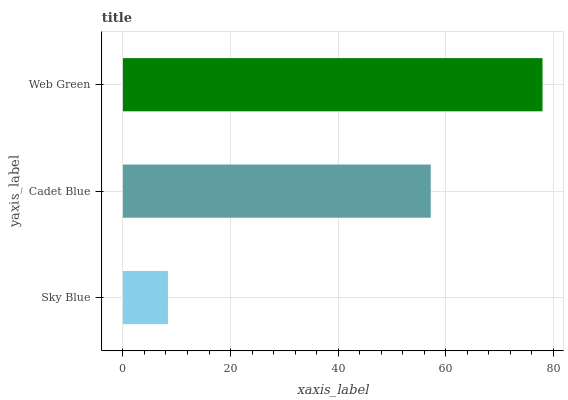Is Sky Blue the minimum?
Answer yes or no. Yes. Is Web Green the maximum?
Answer yes or no. Yes. Is Cadet Blue the minimum?
Answer yes or no. No. Is Cadet Blue the maximum?
Answer yes or no. No. Is Cadet Blue greater than Sky Blue?
Answer yes or no. Yes. Is Sky Blue less than Cadet Blue?
Answer yes or no. Yes. Is Sky Blue greater than Cadet Blue?
Answer yes or no. No. Is Cadet Blue less than Sky Blue?
Answer yes or no. No. Is Cadet Blue the high median?
Answer yes or no. Yes. Is Cadet Blue the low median?
Answer yes or no. Yes. Is Web Green the high median?
Answer yes or no. No. Is Sky Blue the low median?
Answer yes or no. No. 